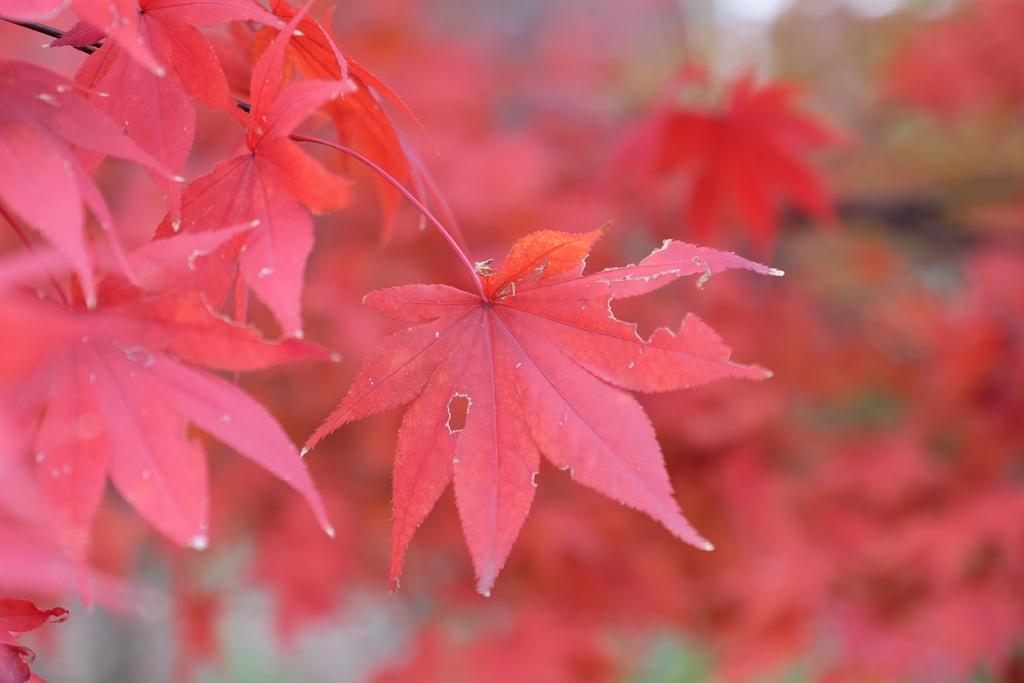Can you describe this image briefly? In this picture we can see red color leaves, there is a blurry background. 